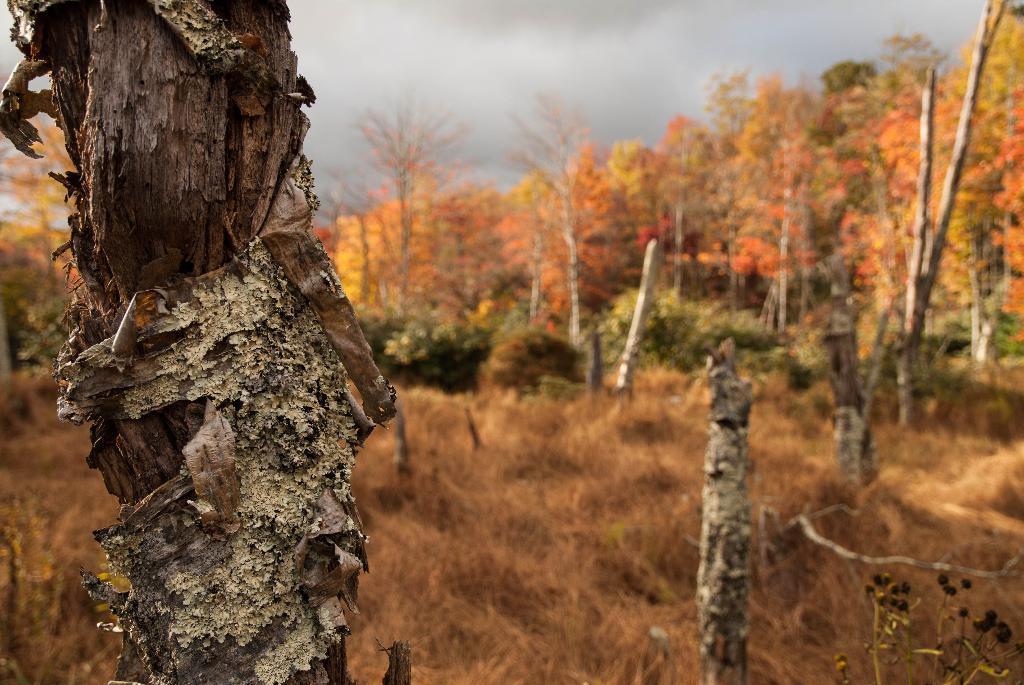In one or two sentences, can you explain what this image depicts? In the picture we can see a tree branch near it, we can see dried grass plants and in the background, we can see trees and behind it we can see the sky with clouds. 